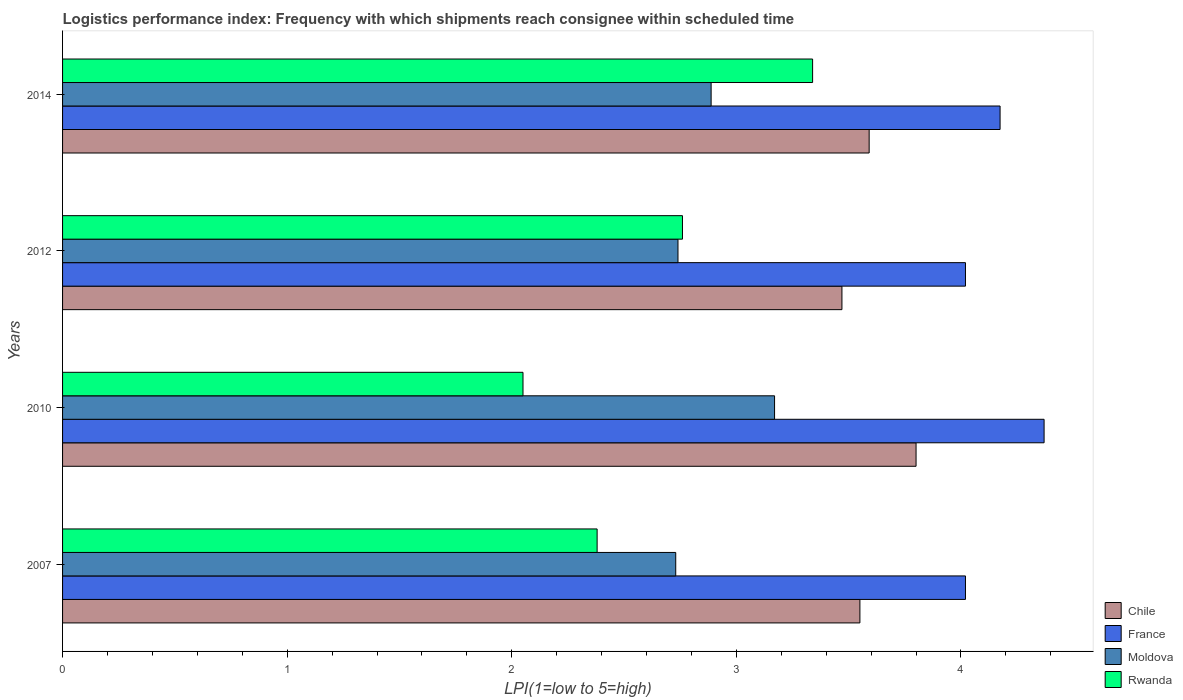Are the number of bars per tick equal to the number of legend labels?
Offer a very short reply. Yes. How many bars are there on the 2nd tick from the top?
Your response must be concise. 4. What is the label of the 2nd group of bars from the top?
Ensure brevity in your answer.  2012. In how many cases, is the number of bars for a given year not equal to the number of legend labels?
Make the answer very short. 0. What is the logistics performance index in Rwanda in 2007?
Give a very brief answer. 2.38. Across all years, what is the maximum logistics performance index in France?
Your answer should be compact. 4.37. Across all years, what is the minimum logistics performance index in France?
Your answer should be very brief. 4.02. In which year was the logistics performance index in Rwanda maximum?
Make the answer very short. 2014. In which year was the logistics performance index in Chile minimum?
Provide a succinct answer. 2012. What is the total logistics performance index in France in the graph?
Make the answer very short. 16.58. What is the difference between the logistics performance index in Rwanda in 2007 and that in 2012?
Provide a succinct answer. -0.38. What is the difference between the logistics performance index in Rwanda in 2014 and the logistics performance index in Chile in 2007?
Offer a very short reply. -0.21. What is the average logistics performance index in Chile per year?
Keep it short and to the point. 3.6. In the year 2010, what is the difference between the logistics performance index in Chile and logistics performance index in Moldova?
Make the answer very short. 0.63. In how many years, is the logistics performance index in Chile greater than 1 ?
Keep it short and to the point. 4. What is the ratio of the logistics performance index in Moldova in 2007 to that in 2012?
Offer a very short reply. 1. What is the difference between the highest and the second highest logistics performance index in Chile?
Make the answer very short. 0.21. What is the difference between the highest and the lowest logistics performance index in Rwanda?
Make the answer very short. 1.29. Is the sum of the logistics performance index in Moldova in 2010 and 2014 greater than the maximum logistics performance index in Chile across all years?
Give a very brief answer. Yes. What does the 2nd bar from the top in 2010 represents?
Offer a terse response. Moldova. What does the 4th bar from the bottom in 2012 represents?
Offer a terse response. Rwanda. Is it the case that in every year, the sum of the logistics performance index in France and logistics performance index in Chile is greater than the logistics performance index in Rwanda?
Keep it short and to the point. Yes. Are all the bars in the graph horizontal?
Give a very brief answer. Yes. What is the difference between two consecutive major ticks on the X-axis?
Your answer should be very brief. 1. How are the legend labels stacked?
Your response must be concise. Vertical. What is the title of the graph?
Provide a short and direct response. Logistics performance index: Frequency with which shipments reach consignee within scheduled time. Does "Dominican Republic" appear as one of the legend labels in the graph?
Ensure brevity in your answer.  No. What is the label or title of the X-axis?
Make the answer very short. LPI(1=low to 5=high). What is the LPI(1=low to 5=high) in Chile in 2007?
Your answer should be compact. 3.55. What is the LPI(1=low to 5=high) in France in 2007?
Offer a very short reply. 4.02. What is the LPI(1=low to 5=high) in Moldova in 2007?
Your response must be concise. 2.73. What is the LPI(1=low to 5=high) of Rwanda in 2007?
Keep it short and to the point. 2.38. What is the LPI(1=low to 5=high) of Chile in 2010?
Your response must be concise. 3.8. What is the LPI(1=low to 5=high) in France in 2010?
Your answer should be very brief. 4.37. What is the LPI(1=low to 5=high) of Moldova in 2010?
Provide a short and direct response. 3.17. What is the LPI(1=low to 5=high) of Rwanda in 2010?
Keep it short and to the point. 2.05. What is the LPI(1=low to 5=high) in Chile in 2012?
Keep it short and to the point. 3.47. What is the LPI(1=low to 5=high) in France in 2012?
Offer a terse response. 4.02. What is the LPI(1=low to 5=high) in Moldova in 2012?
Your answer should be compact. 2.74. What is the LPI(1=low to 5=high) in Rwanda in 2012?
Your answer should be very brief. 2.76. What is the LPI(1=low to 5=high) of Chile in 2014?
Your response must be concise. 3.59. What is the LPI(1=low to 5=high) in France in 2014?
Offer a terse response. 4.17. What is the LPI(1=low to 5=high) of Moldova in 2014?
Make the answer very short. 2.89. What is the LPI(1=low to 5=high) in Rwanda in 2014?
Offer a very short reply. 3.34. Across all years, what is the maximum LPI(1=low to 5=high) in France?
Provide a succinct answer. 4.37. Across all years, what is the maximum LPI(1=low to 5=high) of Moldova?
Give a very brief answer. 3.17. Across all years, what is the maximum LPI(1=low to 5=high) of Rwanda?
Provide a succinct answer. 3.34. Across all years, what is the minimum LPI(1=low to 5=high) of Chile?
Offer a terse response. 3.47. Across all years, what is the minimum LPI(1=low to 5=high) in France?
Keep it short and to the point. 4.02. Across all years, what is the minimum LPI(1=low to 5=high) in Moldova?
Give a very brief answer. 2.73. Across all years, what is the minimum LPI(1=low to 5=high) of Rwanda?
Your answer should be compact. 2.05. What is the total LPI(1=low to 5=high) in Chile in the graph?
Ensure brevity in your answer.  14.41. What is the total LPI(1=low to 5=high) of France in the graph?
Keep it short and to the point. 16.58. What is the total LPI(1=low to 5=high) in Moldova in the graph?
Your answer should be compact. 11.53. What is the total LPI(1=low to 5=high) in Rwanda in the graph?
Provide a short and direct response. 10.53. What is the difference between the LPI(1=low to 5=high) of France in 2007 and that in 2010?
Ensure brevity in your answer.  -0.35. What is the difference between the LPI(1=low to 5=high) of Moldova in 2007 and that in 2010?
Provide a succinct answer. -0.44. What is the difference between the LPI(1=low to 5=high) in Rwanda in 2007 and that in 2010?
Provide a short and direct response. 0.33. What is the difference between the LPI(1=low to 5=high) of Chile in 2007 and that in 2012?
Provide a short and direct response. 0.08. What is the difference between the LPI(1=low to 5=high) of France in 2007 and that in 2012?
Ensure brevity in your answer.  0. What is the difference between the LPI(1=low to 5=high) of Moldova in 2007 and that in 2012?
Keep it short and to the point. -0.01. What is the difference between the LPI(1=low to 5=high) in Rwanda in 2007 and that in 2012?
Make the answer very short. -0.38. What is the difference between the LPI(1=low to 5=high) of Chile in 2007 and that in 2014?
Ensure brevity in your answer.  -0.04. What is the difference between the LPI(1=low to 5=high) in France in 2007 and that in 2014?
Your answer should be compact. -0.15. What is the difference between the LPI(1=low to 5=high) in Moldova in 2007 and that in 2014?
Provide a short and direct response. -0.16. What is the difference between the LPI(1=low to 5=high) in Rwanda in 2007 and that in 2014?
Offer a terse response. -0.96. What is the difference between the LPI(1=low to 5=high) in Chile in 2010 and that in 2012?
Your answer should be very brief. 0.33. What is the difference between the LPI(1=low to 5=high) in Moldova in 2010 and that in 2012?
Ensure brevity in your answer.  0.43. What is the difference between the LPI(1=low to 5=high) in Rwanda in 2010 and that in 2012?
Keep it short and to the point. -0.71. What is the difference between the LPI(1=low to 5=high) in Chile in 2010 and that in 2014?
Your answer should be compact. 0.21. What is the difference between the LPI(1=low to 5=high) of France in 2010 and that in 2014?
Offer a terse response. 0.2. What is the difference between the LPI(1=low to 5=high) of Moldova in 2010 and that in 2014?
Make the answer very short. 0.28. What is the difference between the LPI(1=low to 5=high) in Rwanda in 2010 and that in 2014?
Your answer should be compact. -1.29. What is the difference between the LPI(1=low to 5=high) in Chile in 2012 and that in 2014?
Provide a short and direct response. -0.12. What is the difference between the LPI(1=low to 5=high) of France in 2012 and that in 2014?
Provide a short and direct response. -0.15. What is the difference between the LPI(1=low to 5=high) in Moldova in 2012 and that in 2014?
Your answer should be compact. -0.15. What is the difference between the LPI(1=low to 5=high) in Rwanda in 2012 and that in 2014?
Keep it short and to the point. -0.58. What is the difference between the LPI(1=low to 5=high) in Chile in 2007 and the LPI(1=low to 5=high) in France in 2010?
Your response must be concise. -0.82. What is the difference between the LPI(1=low to 5=high) in Chile in 2007 and the LPI(1=low to 5=high) in Moldova in 2010?
Make the answer very short. 0.38. What is the difference between the LPI(1=low to 5=high) of Chile in 2007 and the LPI(1=low to 5=high) of Rwanda in 2010?
Provide a short and direct response. 1.5. What is the difference between the LPI(1=low to 5=high) of France in 2007 and the LPI(1=low to 5=high) of Moldova in 2010?
Your answer should be very brief. 0.85. What is the difference between the LPI(1=low to 5=high) in France in 2007 and the LPI(1=low to 5=high) in Rwanda in 2010?
Provide a short and direct response. 1.97. What is the difference between the LPI(1=low to 5=high) in Moldova in 2007 and the LPI(1=low to 5=high) in Rwanda in 2010?
Offer a terse response. 0.68. What is the difference between the LPI(1=low to 5=high) in Chile in 2007 and the LPI(1=low to 5=high) in France in 2012?
Ensure brevity in your answer.  -0.47. What is the difference between the LPI(1=low to 5=high) of Chile in 2007 and the LPI(1=low to 5=high) of Moldova in 2012?
Provide a succinct answer. 0.81. What is the difference between the LPI(1=low to 5=high) in Chile in 2007 and the LPI(1=low to 5=high) in Rwanda in 2012?
Give a very brief answer. 0.79. What is the difference between the LPI(1=low to 5=high) in France in 2007 and the LPI(1=low to 5=high) in Moldova in 2012?
Offer a terse response. 1.28. What is the difference between the LPI(1=low to 5=high) of France in 2007 and the LPI(1=low to 5=high) of Rwanda in 2012?
Ensure brevity in your answer.  1.26. What is the difference between the LPI(1=low to 5=high) in Moldova in 2007 and the LPI(1=low to 5=high) in Rwanda in 2012?
Provide a succinct answer. -0.03. What is the difference between the LPI(1=low to 5=high) in Chile in 2007 and the LPI(1=low to 5=high) in France in 2014?
Offer a terse response. -0.62. What is the difference between the LPI(1=low to 5=high) in Chile in 2007 and the LPI(1=low to 5=high) in Moldova in 2014?
Your answer should be compact. 0.66. What is the difference between the LPI(1=low to 5=high) in Chile in 2007 and the LPI(1=low to 5=high) in Rwanda in 2014?
Provide a succinct answer. 0.21. What is the difference between the LPI(1=low to 5=high) of France in 2007 and the LPI(1=low to 5=high) of Moldova in 2014?
Make the answer very short. 1.13. What is the difference between the LPI(1=low to 5=high) of France in 2007 and the LPI(1=low to 5=high) of Rwanda in 2014?
Offer a terse response. 0.68. What is the difference between the LPI(1=low to 5=high) in Moldova in 2007 and the LPI(1=low to 5=high) in Rwanda in 2014?
Make the answer very short. -0.61. What is the difference between the LPI(1=low to 5=high) of Chile in 2010 and the LPI(1=low to 5=high) of France in 2012?
Your response must be concise. -0.22. What is the difference between the LPI(1=low to 5=high) of Chile in 2010 and the LPI(1=low to 5=high) of Moldova in 2012?
Provide a short and direct response. 1.06. What is the difference between the LPI(1=low to 5=high) of France in 2010 and the LPI(1=low to 5=high) of Moldova in 2012?
Make the answer very short. 1.63. What is the difference between the LPI(1=low to 5=high) of France in 2010 and the LPI(1=low to 5=high) of Rwanda in 2012?
Your answer should be compact. 1.61. What is the difference between the LPI(1=low to 5=high) of Moldova in 2010 and the LPI(1=low to 5=high) of Rwanda in 2012?
Offer a very short reply. 0.41. What is the difference between the LPI(1=low to 5=high) of Chile in 2010 and the LPI(1=low to 5=high) of France in 2014?
Ensure brevity in your answer.  -0.37. What is the difference between the LPI(1=low to 5=high) of Chile in 2010 and the LPI(1=low to 5=high) of Moldova in 2014?
Offer a very short reply. 0.91. What is the difference between the LPI(1=low to 5=high) in Chile in 2010 and the LPI(1=low to 5=high) in Rwanda in 2014?
Make the answer very short. 0.46. What is the difference between the LPI(1=low to 5=high) in France in 2010 and the LPI(1=low to 5=high) in Moldova in 2014?
Your answer should be compact. 1.48. What is the difference between the LPI(1=low to 5=high) in France in 2010 and the LPI(1=low to 5=high) in Rwanda in 2014?
Offer a very short reply. 1.03. What is the difference between the LPI(1=low to 5=high) of Moldova in 2010 and the LPI(1=low to 5=high) of Rwanda in 2014?
Provide a short and direct response. -0.17. What is the difference between the LPI(1=low to 5=high) of Chile in 2012 and the LPI(1=low to 5=high) of France in 2014?
Provide a succinct answer. -0.7. What is the difference between the LPI(1=low to 5=high) of Chile in 2012 and the LPI(1=low to 5=high) of Moldova in 2014?
Offer a very short reply. 0.58. What is the difference between the LPI(1=low to 5=high) in Chile in 2012 and the LPI(1=low to 5=high) in Rwanda in 2014?
Provide a succinct answer. 0.13. What is the difference between the LPI(1=low to 5=high) of France in 2012 and the LPI(1=low to 5=high) of Moldova in 2014?
Offer a terse response. 1.13. What is the difference between the LPI(1=low to 5=high) of France in 2012 and the LPI(1=low to 5=high) of Rwanda in 2014?
Keep it short and to the point. 0.68. What is the difference between the LPI(1=low to 5=high) of Moldova in 2012 and the LPI(1=low to 5=high) of Rwanda in 2014?
Make the answer very short. -0.6. What is the average LPI(1=low to 5=high) of Chile per year?
Make the answer very short. 3.6. What is the average LPI(1=low to 5=high) of France per year?
Offer a very short reply. 4.15. What is the average LPI(1=low to 5=high) in Moldova per year?
Provide a short and direct response. 2.88. What is the average LPI(1=low to 5=high) of Rwanda per year?
Ensure brevity in your answer.  2.63. In the year 2007, what is the difference between the LPI(1=low to 5=high) in Chile and LPI(1=low to 5=high) in France?
Make the answer very short. -0.47. In the year 2007, what is the difference between the LPI(1=low to 5=high) in Chile and LPI(1=low to 5=high) in Moldova?
Provide a succinct answer. 0.82. In the year 2007, what is the difference between the LPI(1=low to 5=high) in Chile and LPI(1=low to 5=high) in Rwanda?
Your answer should be compact. 1.17. In the year 2007, what is the difference between the LPI(1=low to 5=high) of France and LPI(1=low to 5=high) of Moldova?
Provide a succinct answer. 1.29. In the year 2007, what is the difference between the LPI(1=low to 5=high) of France and LPI(1=low to 5=high) of Rwanda?
Your response must be concise. 1.64. In the year 2010, what is the difference between the LPI(1=low to 5=high) in Chile and LPI(1=low to 5=high) in France?
Keep it short and to the point. -0.57. In the year 2010, what is the difference between the LPI(1=low to 5=high) of Chile and LPI(1=low to 5=high) of Moldova?
Give a very brief answer. 0.63. In the year 2010, what is the difference between the LPI(1=low to 5=high) in France and LPI(1=low to 5=high) in Rwanda?
Give a very brief answer. 2.32. In the year 2010, what is the difference between the LPI(1=low to 5=high) in Moldova and LPI(1=low to 5=high) in Rwanda?
Your response must be concise. 1.12. In the year 2012, what is the difference between the LPI(1=low to 5=high) in Chile and LPI(1=low to 5=high) in France?
Your response must be concise. -0.55. In the year 2012, what is the difference between the LPI(1=low to 5=high) in Chile and LPI(1=low to 5=high) in Moldova?
Your answer should be compact. 0.73. In the year 2012, what is the difference between the LPI(1=low to 5=high) of Chile and LPI(1=low to 5=high) of Rwanda?
Provide a short and direct response. 0.71. In the year 2012, what is the difference between the LPI(1=low to 5=high) of France and LPI(1=low to 5=high) of Moldova?
Make the answer very short. 1.28. In the year 2012, what is the difference between the LPI(1=low to 5=high) in France and LPI(1=low to 5=high) in Rwanda?
Your answer should be very brief. 1.26. In the year 2012, what is the difference between the LPI(1=low to 5=high) of Moldova and LPI(1=low to 5=high) of Rwanda?
Offer a terse response. -0.02. In the year 2014, what is the difference between the LPI(1=low to 5=high) in Chile and LPI(1=low to 5=high) in France?
Provide a short and direct response. -0.58. In the year 2014, what is the difference between the LPI(1=low to 5=high) in Chile and LPI(1=low to 5=high) in Moldova?
Your answer should be very brief. 0.7. In the year 2014, what is the difference between the LPI(1=low to 5=high) of Chile and LPI(1=low to 5=high) of Rwanda?
Make the answer very short. 0.25. In the year 2014, what is the difference between the LPI(1=low to 5=high) of France and LPI(1=low to 5=high) of Moldova?
Provide a succinct answer. 1.29. In the year 2014, what is the difference between the LPI(1=low to 5=high) in France and LPI(1=low to 5=high) in Rwanda?
Keep it short and to the point. 0.83. In the year 2014, what is the difference between the LPI(1=low to 5=high) of Moldova and LPI(1=low to 5=high) of Rwanda?
Your answer should be compact. -0.45. What is the ratio of the LPI(1=low to 5=high) of Chile in 2007 to that in 2010?
Offer a terse response. 0.93. What is the ratio of the LPI(1=low to 5=high) in France in 2007 to that in 2010?
Ensure brevity in your answer.  0.92. What is the ratio of the LPI(1=low to 5=high) in Moldova in 2007 to that in 2010?
Offer a terse response. 0.86. What is the ratio of the LPI(1=low to 5=high) of Rwanda in 2007 to that in 2010?
Make the answer very short. 1.16. What is the ratio of the LPI(1=low to 5=high) in Chile in 2007 to that in 2012?
Make the answer very short. 1.02. What is the ratio of the LPI(1=low to 5=high) of Rwanda in 2007 to that in 2012?
Your response must be concise. 0.86. What is the ratio of the LPI(1=low to 5=high) of Chile in 2007 to that in 2014?
Give a very brief answer. 0.99. What is the ratio of the LPI(1=low to 5=high) in France in 2007 to that in 2014?
Give a very brief answer. 0.96. What is the ratio of the LPI(1=low to 5=high) in Moldova in 2007 to that in 2014?
Your answer should be compact. 0.95. What is the ratio of the LPI(1=low to 5=high) of Rwanda in 2007 to that in 2014?
Provide a succinct answer. 0.71. What is the ratio of the LPI(1=low to 5=high) of Chile in 2010 to that in 2012?
Keep it short and to the point. 1.1. What is the ratio of the LPI(1=low to 5=high) of France in 2010 to that in 2012?
Your response must be concise. 1.09. What is the ratio of the LPI(1=low to 5=high) of Moldova in 2010 to that in 2012?
Offer a very short reply. 1.16. What is the ratio of the LPI(1=low to 5=high) in Rwanda in 2010 to that in 2012?
Keep it short and to the point. 0.74. What is the ratio of the LPI(1=low to 5=high) in Chile in 2010 to that in 2014?
Offer a terse response. 1.06. What is the ratio of the LPI(1=low to 5=high) in France in 2010 to that in 2014?
Your response must be concise. 1.05. What is the ratio of the LPI(1=low to 5=high) in Moldova in 2010 to that in 2014?
Your answer should be compact. 1.1. What is the ratio of the LPI(1=low to 5=high) in Rwanda in 2010 to that in 2014?
Make the answer very short. 0.61. What is the ratio of the LPI(1=low to 5=high) in Chile in 2012 to that in 2014?
Your answer should be very brief. 0.97. What is the ratio of the LPI(1=low to 5=high) in France in 2012 to that in 2014?
Your response must be concise. 0.96. What is the ratio of the LPI(1=low to 5=high) of Moldova in 2012 to that in 2014?
Make the answer very short. 0.95. What is the ratio of the LPI(1=low to 5=high) of Rwanda in 2012 to that in 2014?
Provide a short and direct response. 0.83. What is the difference between the highest and the second highest LPI(1=low to 5=high) in Chile?
Provide a short and direct response. 0.21. What is the difference between the highest and the second highest LPI(1=low to 5=high) of France?
Make the answer very short. 0.2. What is the difference between the highest and the second highest LPI(1=low to 5=high) of Moldova?
Your answer should be very brief. 0.28. What is the difference between the highest and the second highest LPI(1=low to 5=high) in Rwanda?
Your answer should be compact. 0.58. What is the difference between the highest and the lowest LPI(1=low to 5=high) in Chile?
Offer a very short reply. 0.33. What is the difference between the highest and the lowest LPI(1=low to 5=high) in France?
Your answer should be very brief. 0.35. What is the difference between the highest and the lowest LPI(1=low to 5=high) of Moldova?
Offer a very short reply. 0.44. What is the difference between the highest and the lowest LPI(1=low to 5=high) of Rwanda?
Ensure brevity in your answer.  1.29. 